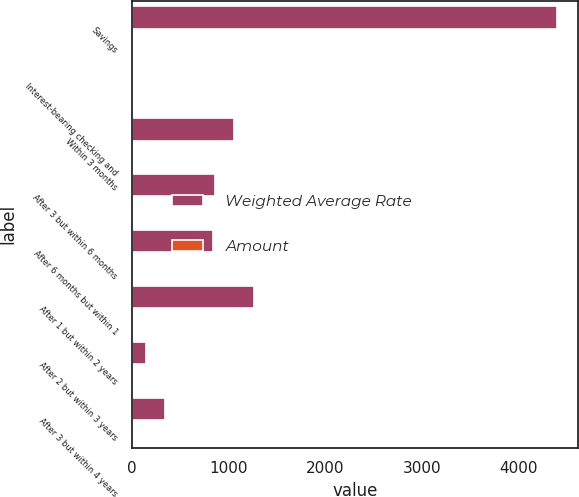Convert chart to OTSL. <chart><loc_0><loc_0><loc_500><loc_500><stacked_bar_chart><ecel><fcel>Savings<fcel>Interest-bearing checking and<fcel>Within 3 months<fcel>After 3 but within 6 months<fcel>After 6 months but within 1<fcel>After 1 but within 2 years<fcel>After 2 but within 3 years<fcel>After 3 but within 4 years<nl><fcel>Weighted Average Rate<fcel>4397.7<fcel>1.81<fcel>1054.9<fcel>852.4<fcel>835.2<fcel>1256.3<fcel>142.7<fcel>335.1<nl><fcel>Amount<fcel>0.14<fcel>0.27<fcel>0.7<fcel>0.75<fcel>0.75<fcel>1.09<fcel>1.26<fcel>1.81<nl></chart> 